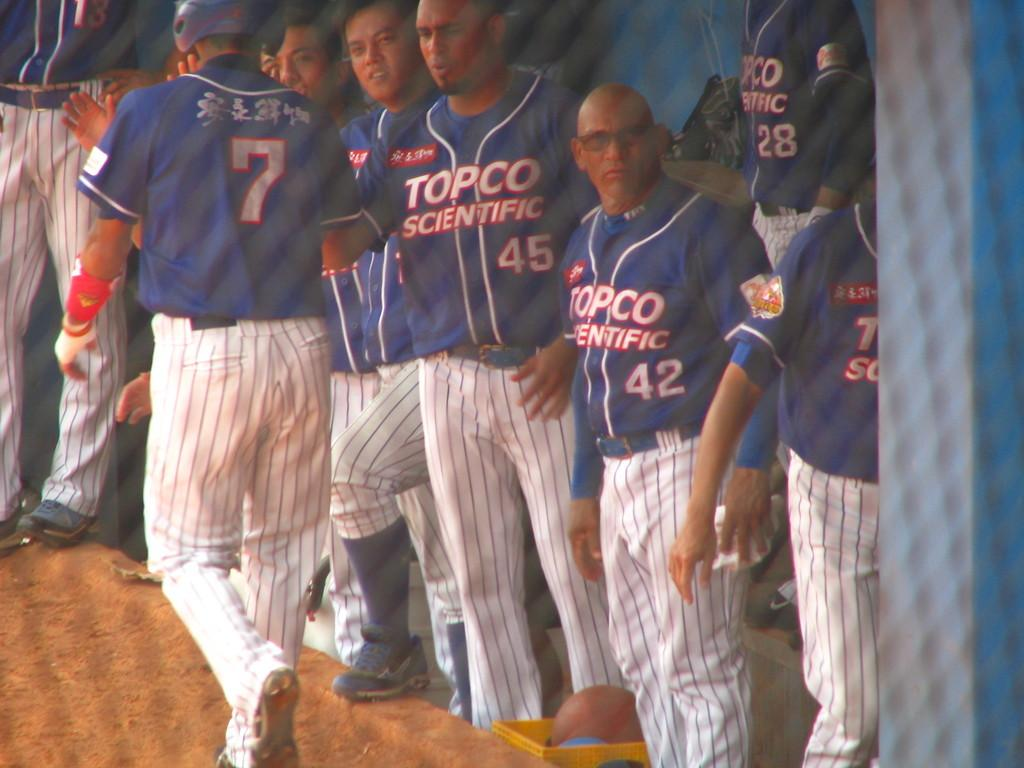<image>
Relay a brief, clear account of the picture shown. Topco Scientific baseball players congratulate player number 7 after scoring. 